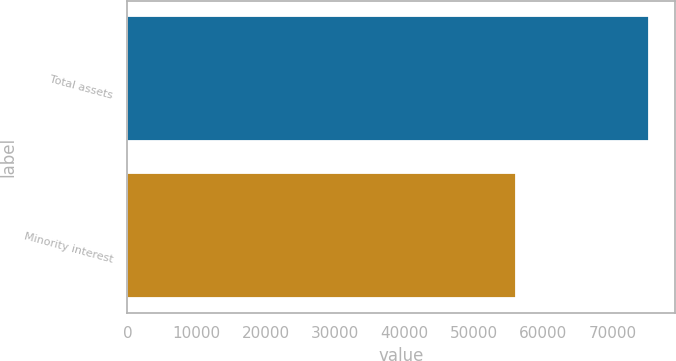<chart> <loc_0><loc_0><loc_500><loc_500><bar_chart><fcel>Total assets<fcel>Minority interest<nl><fcel>75325<fcel>56024<nl></chart> 